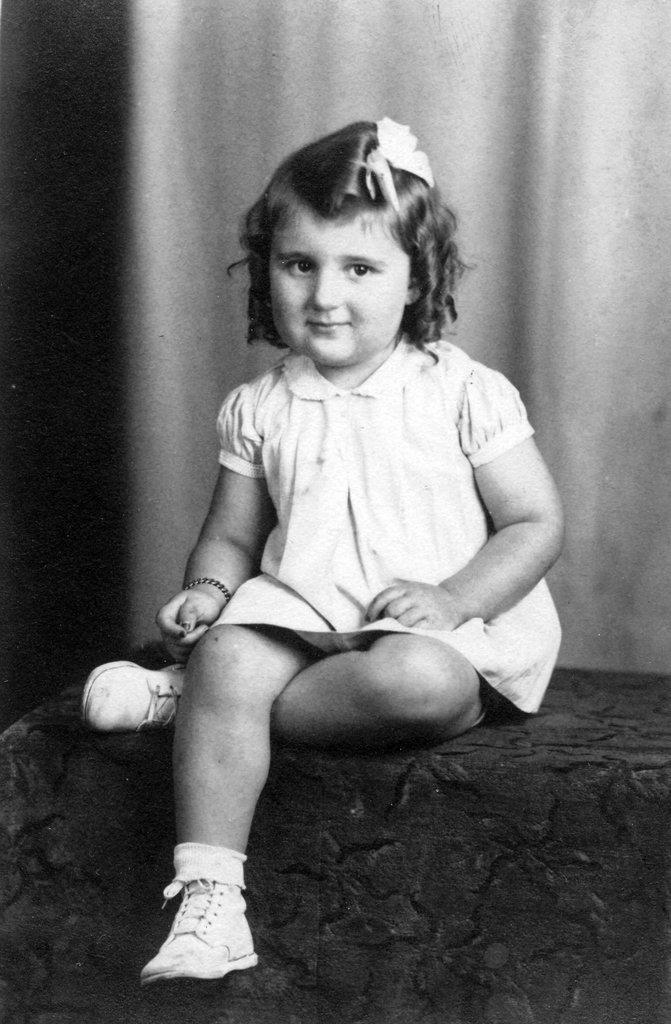Who is the main subject in the image? There is a girl in the image. What is the girl doing in the image? The girl is sitting on a surface. What can be seen behind the girl in the image? There is a cloth visible behind the girl. How many times does the girl stretch her neck in the image? There is no indication in the image that the girl is stretching her neck, so it cannot be determined from the picture. 